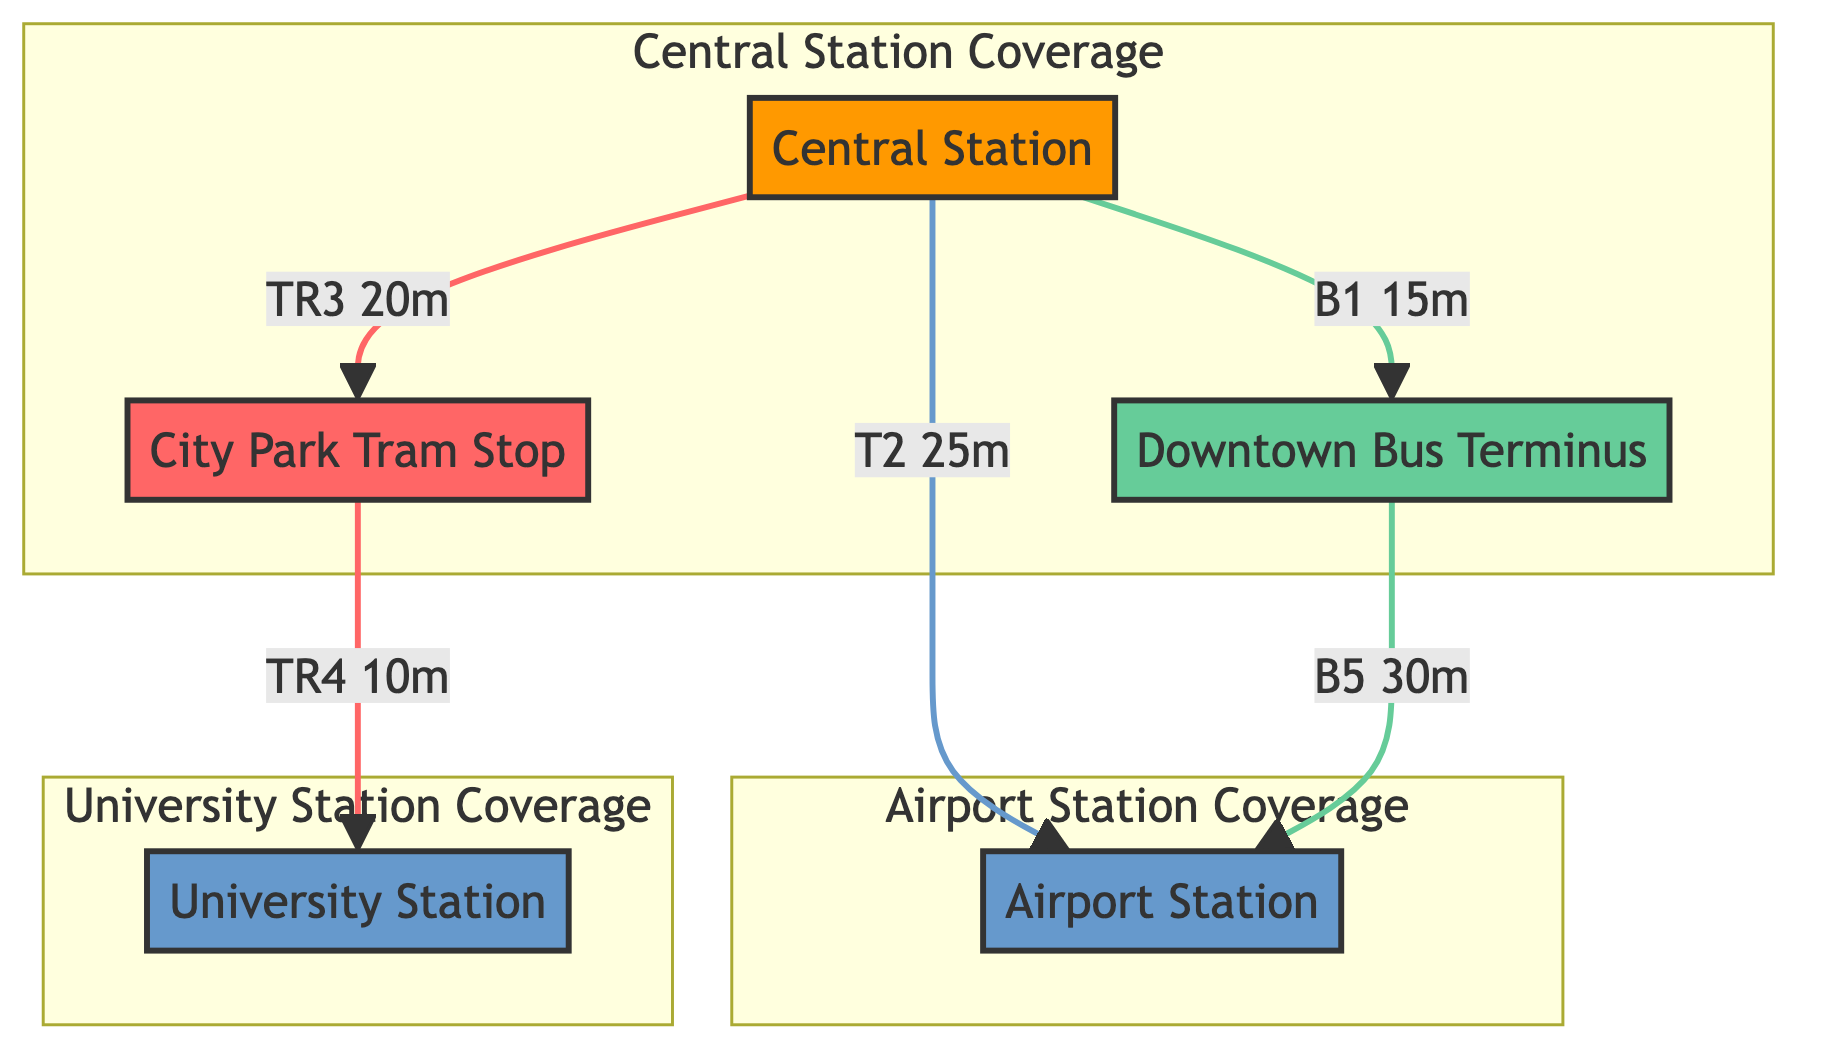What is the travel time from Central Station to Downtown Bus Terminus? The connection from Central Station to Downtown Bus Terminus is labeled as a bus route B1 with a travel time of 15 minutes.
Answer: 15 mins How many types of transport are shown in the diagram? The diagram includes three types of transport: bus, tram, and train. This can be seen through the classifications for the routes between nodes.
Answer: 3 Which hub is connected to the Airport Station? The Airport Station is connected to Central Station by a train route labeled T2, indicating Central Station is the hub connected to it.
Answer: Central Station What is the route number for the tram connection between City Park Tram Stop and University Station? The connection between City Park Tram Stop and University Station is labeled TR4, indicating that TR4 is the tram route number.
Answer: TR4 How many total nodes are present in the diagram? Counting the nodes listed in the provided data, there are five nodes representing different stations and stops: Central Station, Downtown Bus Terminus, Airport Station, City Park Tram Stop, and University Station.
Answer: 5 If someone is at Downtown Bus Terminus, what is the travel time to Airport Station? The connection from Downtown Bus Terminus to Airport Station is shown as a bus route B5 with a travel time of 30 minutes.
Answer: 30 mins Is there a direct tram connection from Central Station to any other stop? In the diagram, there is no direct tram connection from Central Station; instead, it has bus and train routes to other locations.
Answer: No What are the two locations covered in the Airport Station coverage area? The Airport Station coverage includes Airport Station itself and Downtown Bus Terminus, which are specifically listed in the coverage area details.
Answer: Airport Station, Downtown Bus Terminus What type of transfer point exists between City Park Tram Stop and University Station? The transfer type between City Park Tram Stop and University Station is classified as a tram stop, indicating the nature of the transfer there.
Answer: tram stop 